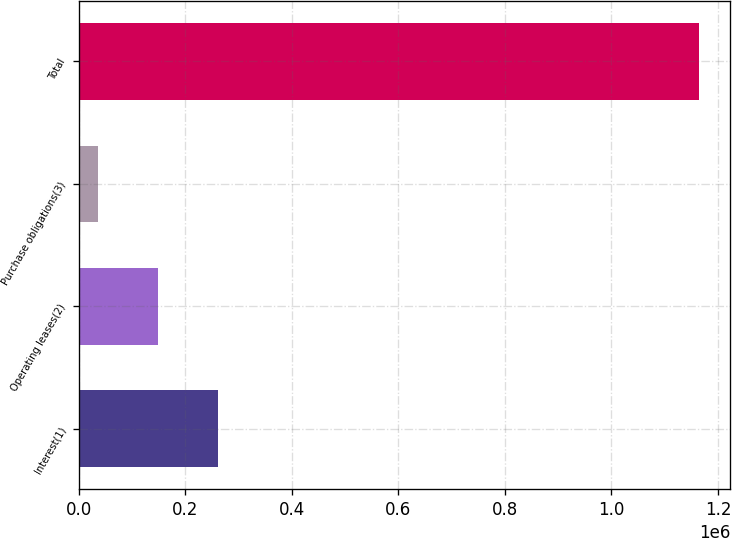Convert chart. <chart><loc_0><loc_0><loc_500><loc_500><bar_chart><fcel>Interest(1)<fcel>Operating leases(2)<fcel>Purchase obligations(3)<fcel>Total<nl><fcel>261003<fcel>148052<fcel>35101<fcel>1.16461e+06<nl></chart> 